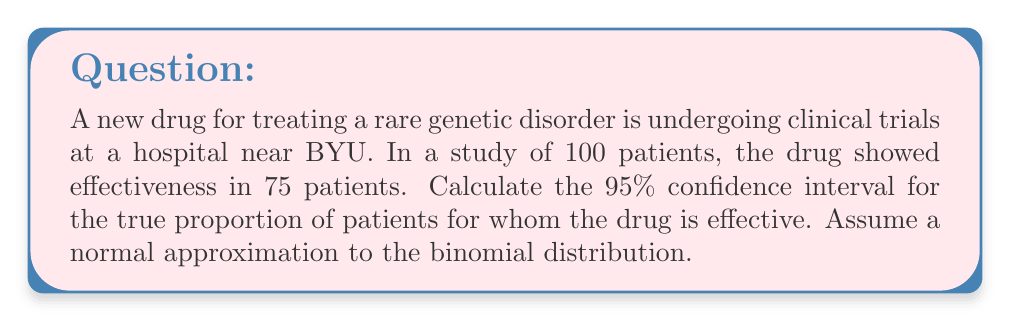Can you solve this math problem? Let's approach this step-by-step:

1) First, we need to identify our sample proportion $\hat{p}$ and sample size $n$:
   $\hat{p} = \frac{75}{100} = 0.75$
   $n = 100$

2) For a 95% confidence interval, we use a z-score of 1.96 (from the standard normal distribution).

3) The formula for the confidence interval is:

   $$\hat{p} \pm z \sqrt{\frac{\hat{p}(1-\hat{p})}{n}}$$

4) Let's calculate the standard error:
   $$SE = \sqrt{\frac{\hat{p}(1-\hat{p})}{n}} = \sqrt{\frac{0.75(1-0.75)}{100}} = \sqrt{\frac{0.1875}{100}} = 0.0433$$

5) Now we can calculate the margin of error:
   $$ME = 1.96 \times 0.0433 = 0.0849$$

6) Finally, we can compute the confidence interval:
   Lower bound: $0.75 - 0.0849 = 0.6651$
   Upper bound: $0.75 + 0.0849 = 0.8349$

Therefore, we are 95% confident that the true proportion of patients for whom the drug is effective lies between 0.6651 and 0.8349, or approximately 66.51% to 83.49%.
Answer: (0.6651, 0.8349) 